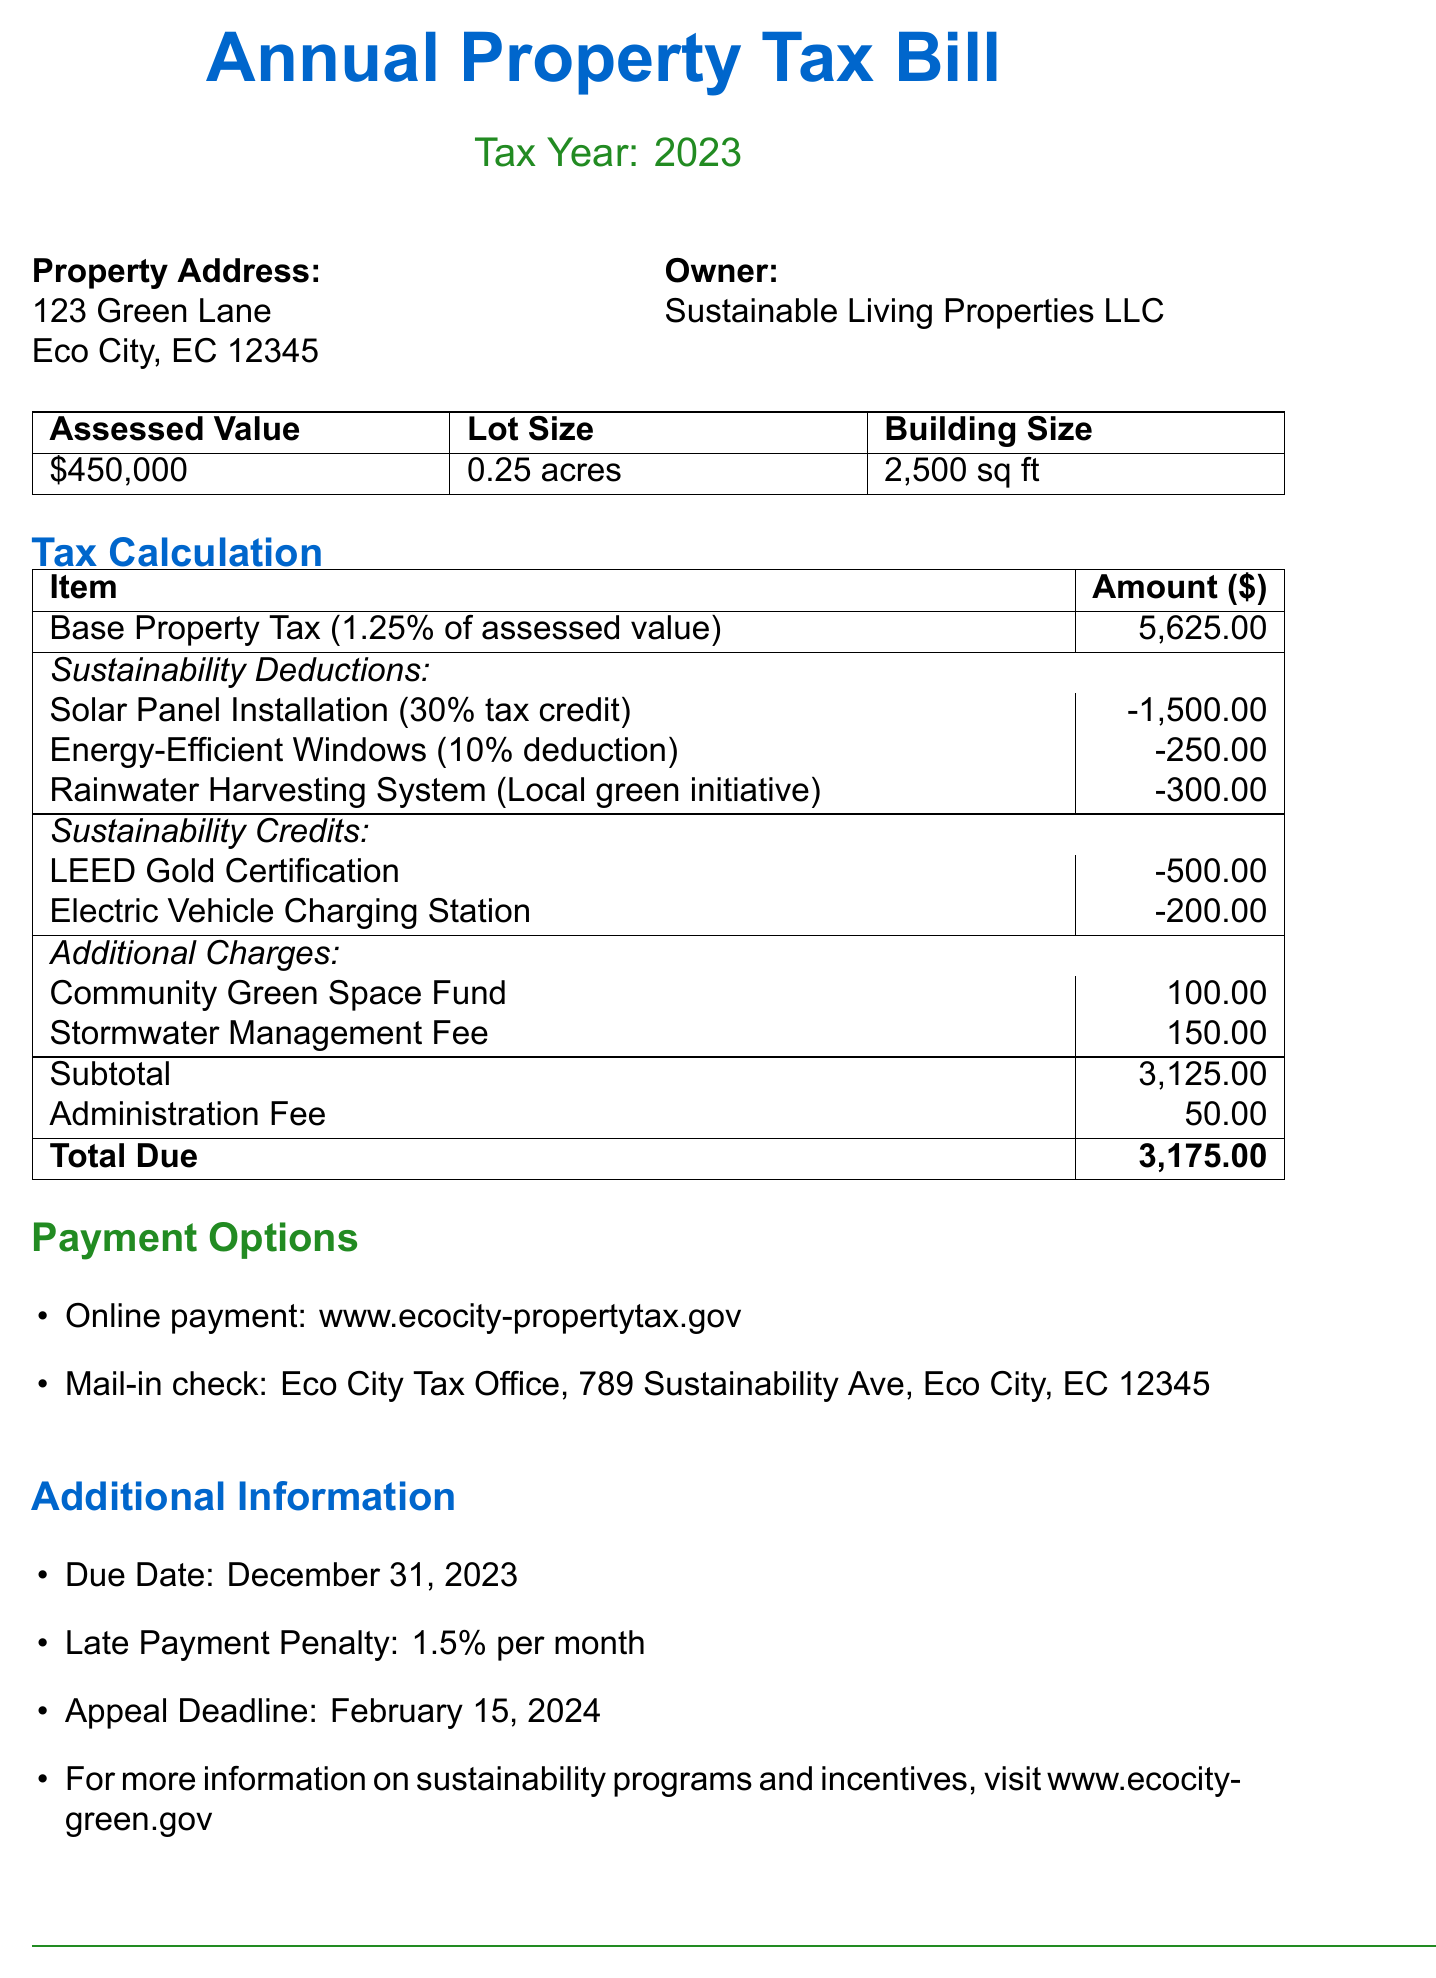What is the property address? The property address is listed in the document under the property details section.
Answer: 123 Green Lane, Eco City, EC 12345 What is the assessed value of the property? The assessed value is provided in the property details section.
Answer: $450,000 What is the base property tax amount? The base property tax amount is calculated based on the assessed value and listed in the tax calculation section.
Answer: $5,625.00 What sustainability deductions are applied to the tax bill? The document lists sustainability deductions that reduce the overall tax amount, along with their descriptions.
Answer: Solar Panel Installation, Energy-Efficient Windows, Rainwater Harvesting System What is the total due amount? The total due is the final amount after deductions, credits, and additional charges, presented in the total calculation section.
Answer: $3,175.00 What is the due date for the payment? The due date for the payment is explicitly stated in the additional information section.
Answer: December 31, 2023 What percentage is the late payment penalty? The late payment penalty percentage is mentioned in the additional information section.
Answer: 1.5% How can I make an online payment? The payment options section contains a website for making an online payment.
Answer: www.ecocity-propertytax.gov What is the appeal deadline? The appeal deadline is provided in the additional information section of the document.
Answer: February 15, 2024 What is LEED Certification? The document mentions LEED Certification in the sustainability credits section with its significance noted.
Answer: Property achieved LEED Gold status 